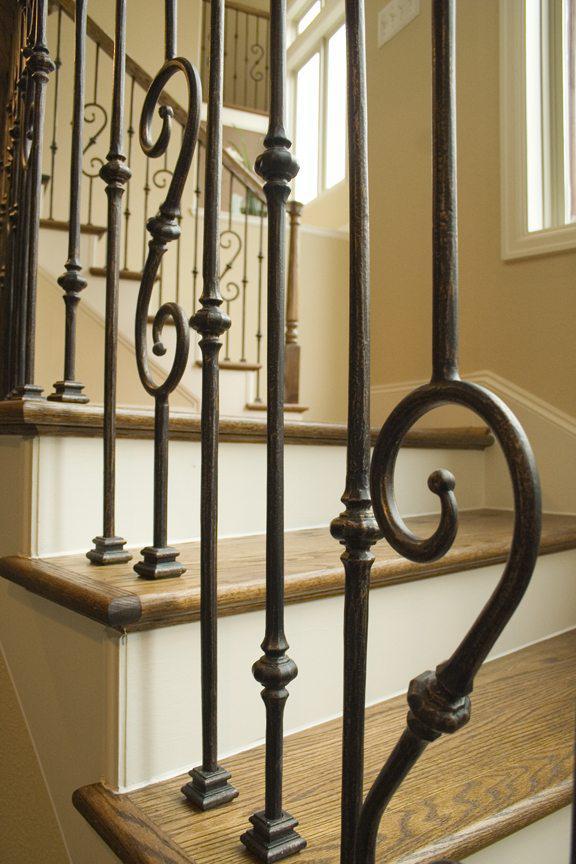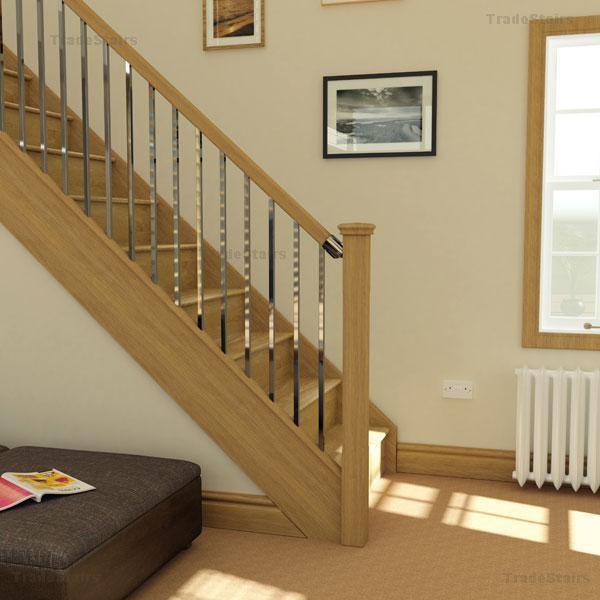The first image is the image on the left, the second image is the image on the right. Analyze the images presented: Is the assertion "There are at least four S shaped pieces of metal in the railing by the stairs." valid? Answer yes or no. Yes. The first image is the image on the left, the second image is the image on the right. Considering the images on both sides, is "The staircase on the left has a banister featuring cast iron bars with scroll details, and the staircase on the right has slender spindles." valid? Answer yes or no. Yes. 